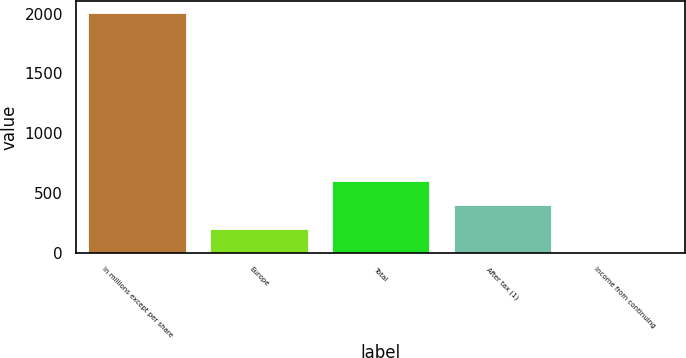Convert chart to OTSL. <chart><loc_0><loc_0><loc_500><loc_500><bar_chart><fcel>In millions except per share<fcel>Europe<fcel>Total<fcel>After tax (1)<fcel>Income from continuing<nl><fcel>2006<fcel>200.67<fcel>601.85<fcel>401.26<fcel>0.08<nl></chart> 